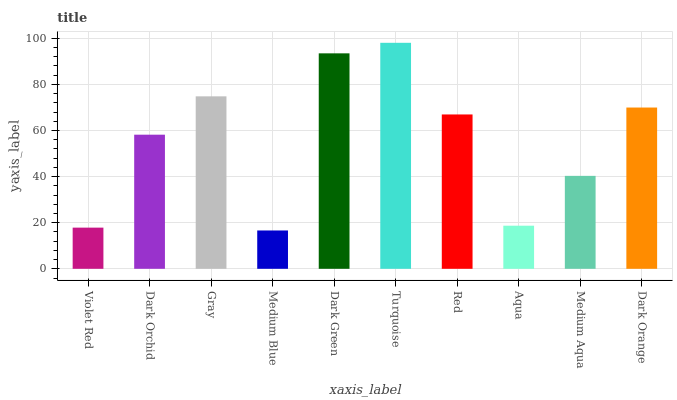Is Medium Blue the minimum?
Answer yes or no. Yes. Is Turquoise the maximum?
Answer yes or no. Yes. Is Dark Orchid the minimum?
Answer yes or no. No. Is Dark Orchid the maximum?
Answer yes or no. No. Is Dark Orchid greater than Violet Red?
Answer yes or no. Yes. Is Violet Red less than Dark Orchid?
Answer yes or no. Yes. Is Violet Red greater than Dark Orchid?
Answer yes or no. No. Is Dark Orchid less than Violet Red?
Answer yes or no. No. Is Red the high median?
Answer yes or no. Yes. Is Dark Orchid the low median?
Answer yes or no. Yes. Is Violet Red the high median?
Answer yes or no. No. Is Dark Green the low median?
Answer yes or no. No. 